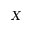Convert formula to latex. <formula><loc_0><loc_0><loc_500><loc_500>X</formula> 